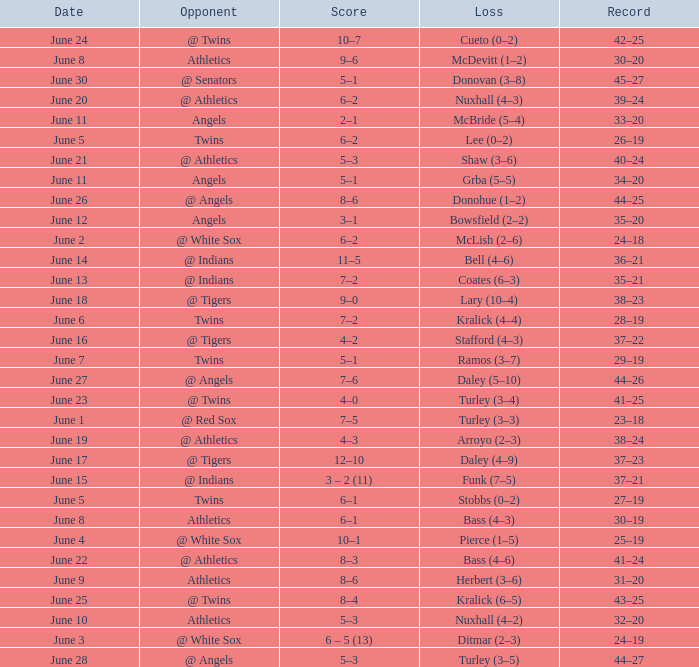What was the score from the game played on June 22? 8–3. 